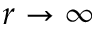<formula> <loc_0><loc_0><loc_500><loc_500>r \to \infty</formula> 